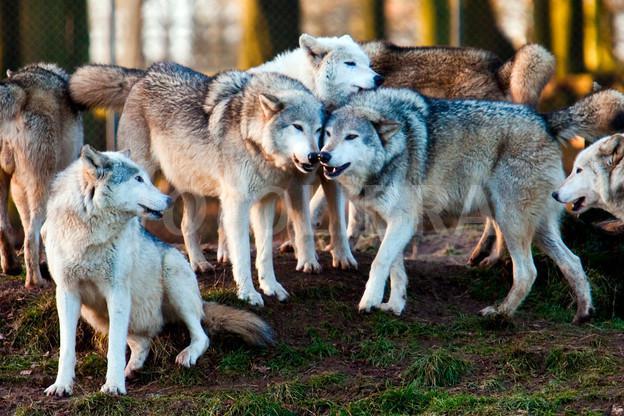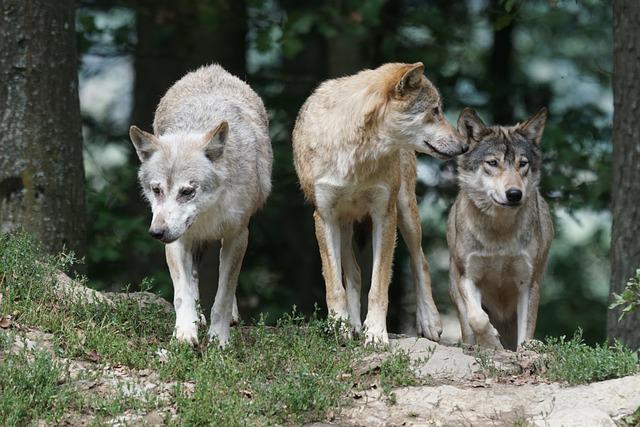The first image is the image on the left, the second image is the image on the right. Analyze the images presented: Is the assertion "There are only two wolves." valid? Answer yes or no. No. The first image is the image on the left, the second image is the image on the right. Considering the images on both sides, is "One image contains exactly three wolves posed in a row with their bodies angled forward." valid? Answer yes or no. Yes. 